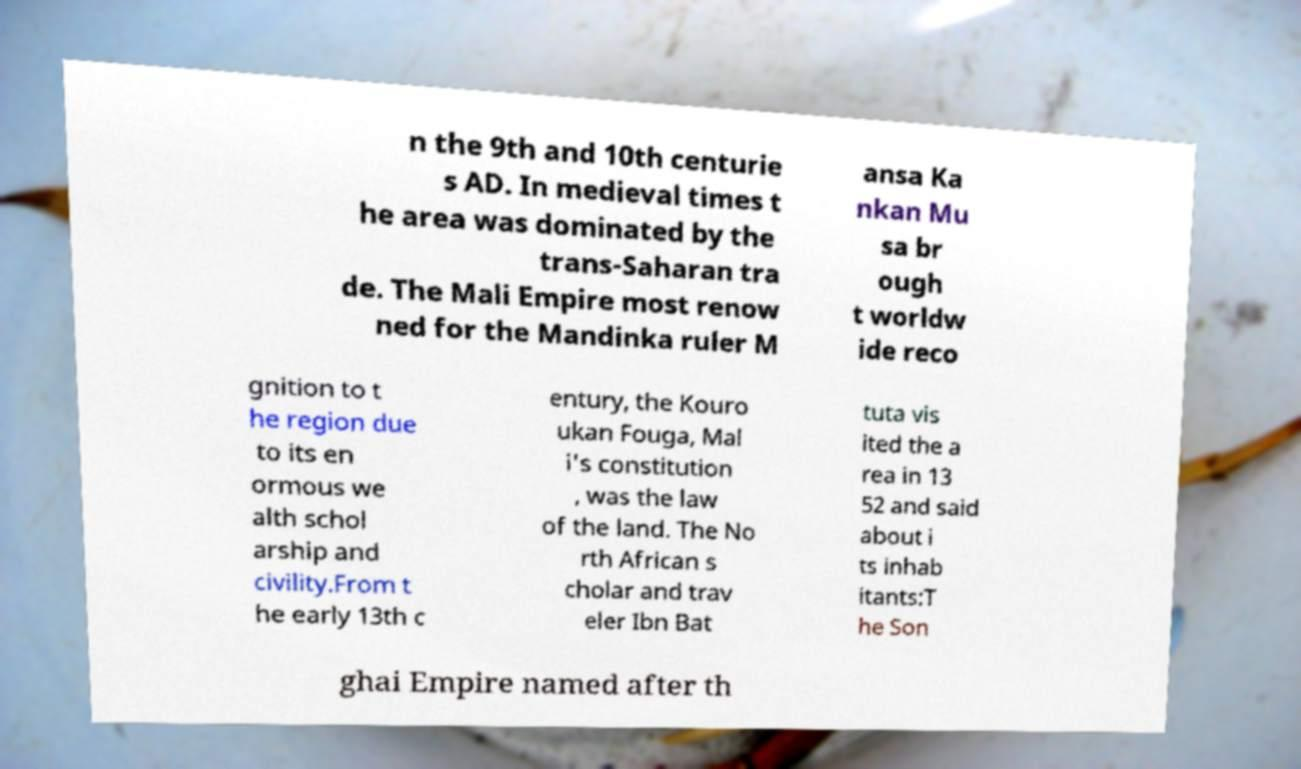Can you accurately transcribe the text from the provided image for me? n the 9th and 10th centurie s AD. In medieval times t he area was dominated by the trans-Saharan tra de. The Mali Empire most renow ned for the Mandinka ruler M ansa Ka nkan Mu sa br ough t worldw ide reco gnition to t he region due to its en ormous we alth schol arship and civility.From t he early 13th c entury, the Kouro ukan Fouga, Mal i's constitution , was the law of the land. The No rth African s cholar and trav eler Ibn Bat tuta vis ited the a rea in 13 52 and said about i ts inhab itants:T he Son ghai Empire named after th 